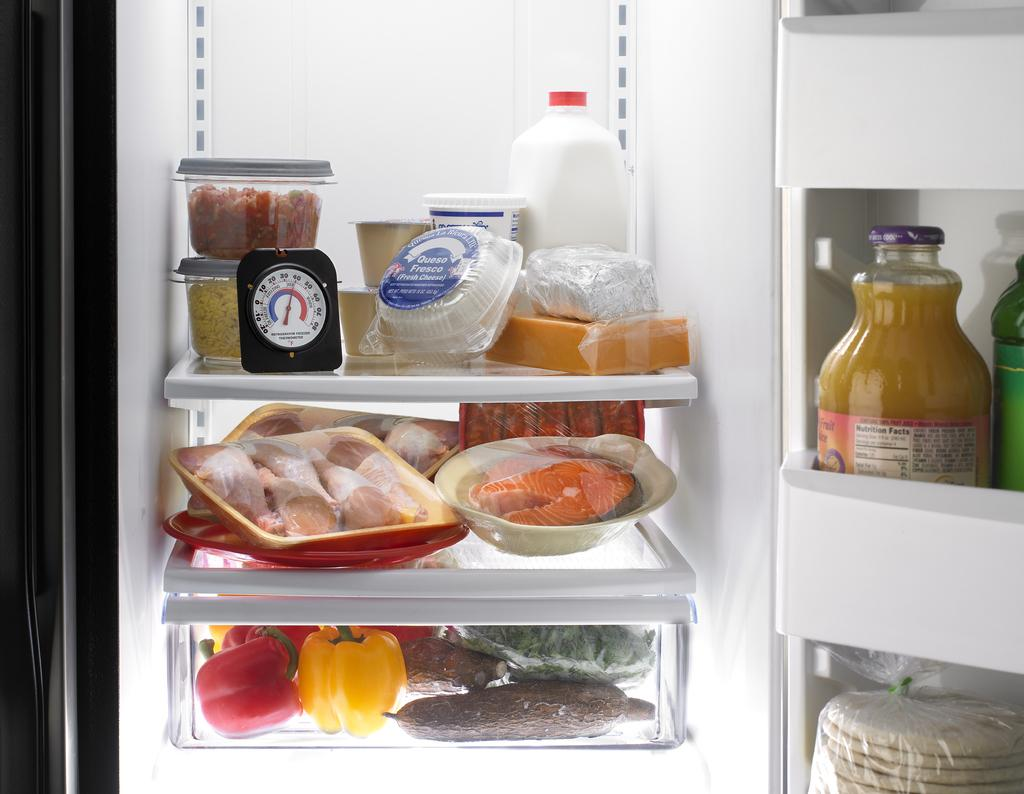What type of containers are visible in the image? There are boxes in the image. What type of produce can be seen in the image? There are vegetables in the image. What type of liquid containers are present in the image? There are bottles in the image. What type of edible items are visible in the image? There are food items in the image. Where are these objects located? The objects are inside a refrigerator. What type of knife is being used to point at the popcorn in the image? There is no knife or popcorn present in the image. 